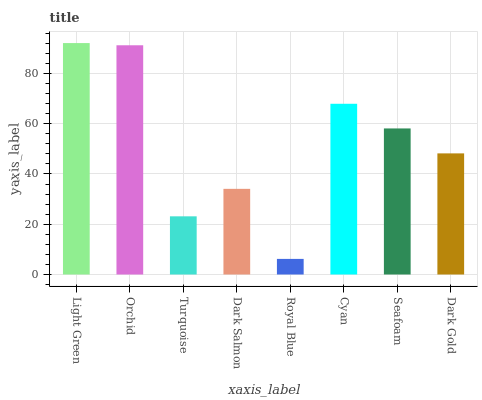Is Royal Blue the minimum?
Answer yes or no. Yes. Is Light Green the maximum?
Answer yes or no. Yes. Is Orchid the minimum?
Answer yes or no. No. Is Orchid the maximum?
Answer yes or no. No. Is Light Green greater than Orchid?
Answer yes or no. Yes. Is Orchid less than Light Green?
Answer yes or no. Yes. Is Orchid greater than Light Green?
Answer yes or no. No. Is Light Green less than Orchid?
Answer yes or no. No. Is Seafoam the high median?
Answer yes or no. Yes. Is Dark Gold the low median?
Answer yes or no. Yes. Is Dark Salmon the high median?
Answer yes or no. No. Is Royal Blue the low median?
Answer yes or no. No. 